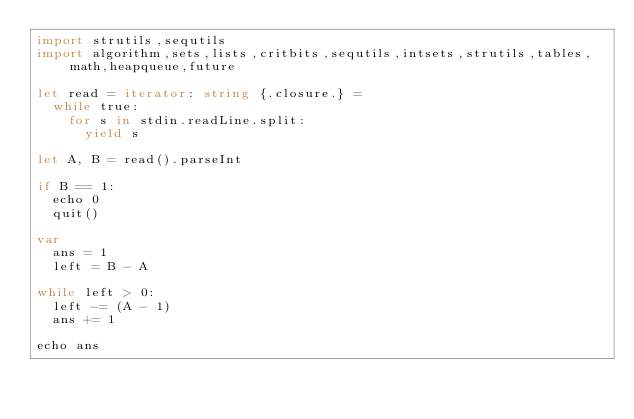<code> <loc_0><loc_0><loc_500><loc_500><_Nim_>import strutils,sequtils
import algorithm,sets,lists,critbits,sequtils,intsets,strutils,tables,math,heapqueue,future

let read = iterator: string {.closure.} =
  while true:
    for s in stdin.readLine.split:
      yield s

let A, B = read().parseInt

if B == 1:
  echo 0
  quit()

var
  ans = 1
  left = B - A

while left > 0:
  left -= (A - 1)
  ans += 1

echo ans
</code> 